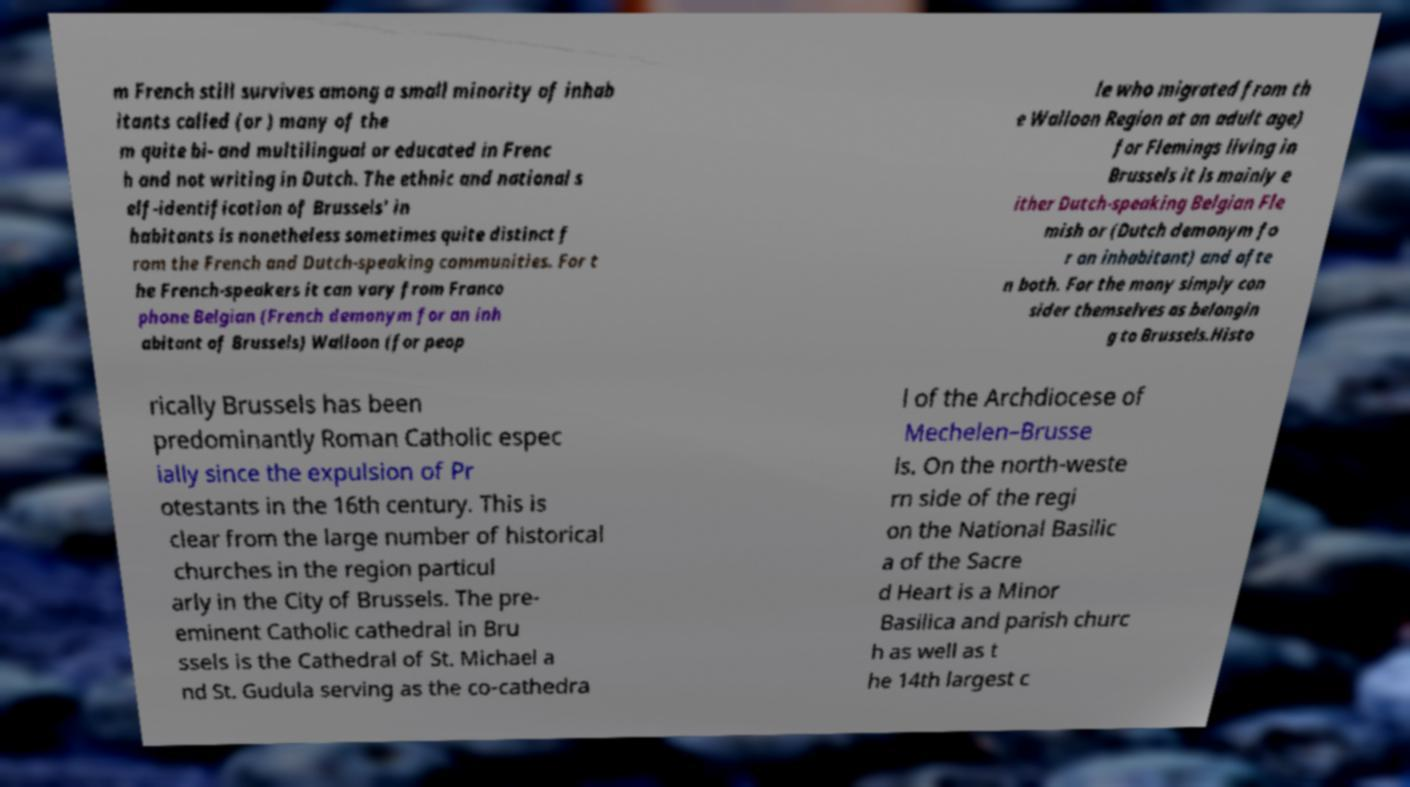Could you assist in decoding the text presented in this image and type it out clearly? m French still survives among a small minority of inhab itants called (or ) many of the m quite bi- and multilingual or educated in Frenc h and not writing in Dutch. The ethnic and national s elf-identification of Brussels' in habitants is nonetheless sometimes quite distinct f rom the French and Dutch-speaking communities. For t he French-speakers it can vary from Franco phone Belgian (French demonym for an inh abitant of Brussels) Walloon (for peop le who migrated from th e Walloon Region at an adult age) for Flemings living in Brussels it is mainly e ither Dutch-speaking Belgian Fle mish or (Dutch demonym fo r an inhabitant) and ofte n both. For the many simply con sider themselves as belongin g to Brussels.Histo rically Brussels has been predominantly Roman Catholic espec ially since the expulsion of Pr otestants in the 16th century. This is clear from the large number of historical churches in the region particul arly in the City of Brussels. The pre- eminent Catholic cathedral in Bru ssels is the Cathedral of St. Michael a nd St. Gudula serving as the co-cathedra l of the Archdiocese of Mechelen–Brusse ls. On the north-weste rn side of the regi on the National Basilic a of the Sacre d Heart is a Minor Basilica and parish churc h as well as t he 14th largest c 